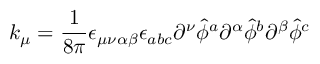Convert formula to latex. <formula><loc_0><loc_0><loc_500><loc_500>k _ { \mu } = { \frac { 1 } { 8 \pi } } \epsilon _ { \mu \nu \alpha \beta } \epsilon _ { a b c } \partial ^ { \nu } { \hat { \phi } } ^ { a } \partial ^ { \alpha } { \hat { \phi } } ^ { b } \partial ^ { \beta } { \hat { \phi } } ^ { c }</formula> 